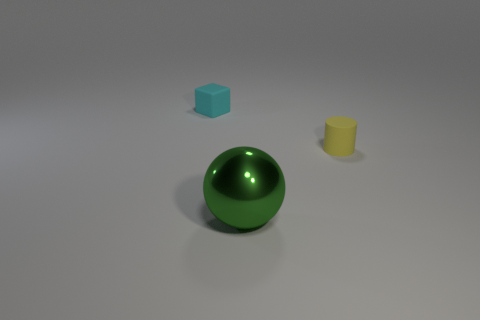Subtract all balls. How many objects are left? 2 Add 1 purple rubber cubes. How many objects exist? 4 Subtract 0 cyan cylinders. How many objects are left? 3 Subtract all big gray objects. Subtract all small cyan matte cubes. How many objects are left? 2 Add 2 spheres. How many spheres are left? 3 Add 1 large shiny objects. How many large shiny objects exist? 2 